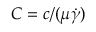<formula> <loc_0><loc_0><loc_500><loc_500>C = c / ( \mu \dot { \gamma } )</formula> 